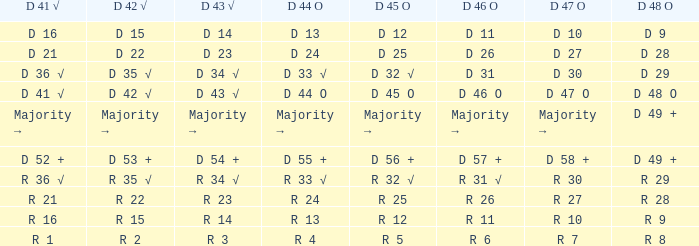Determine the d 45 o in conjunction with the d 46 o of r 31 √. R 32 √. 